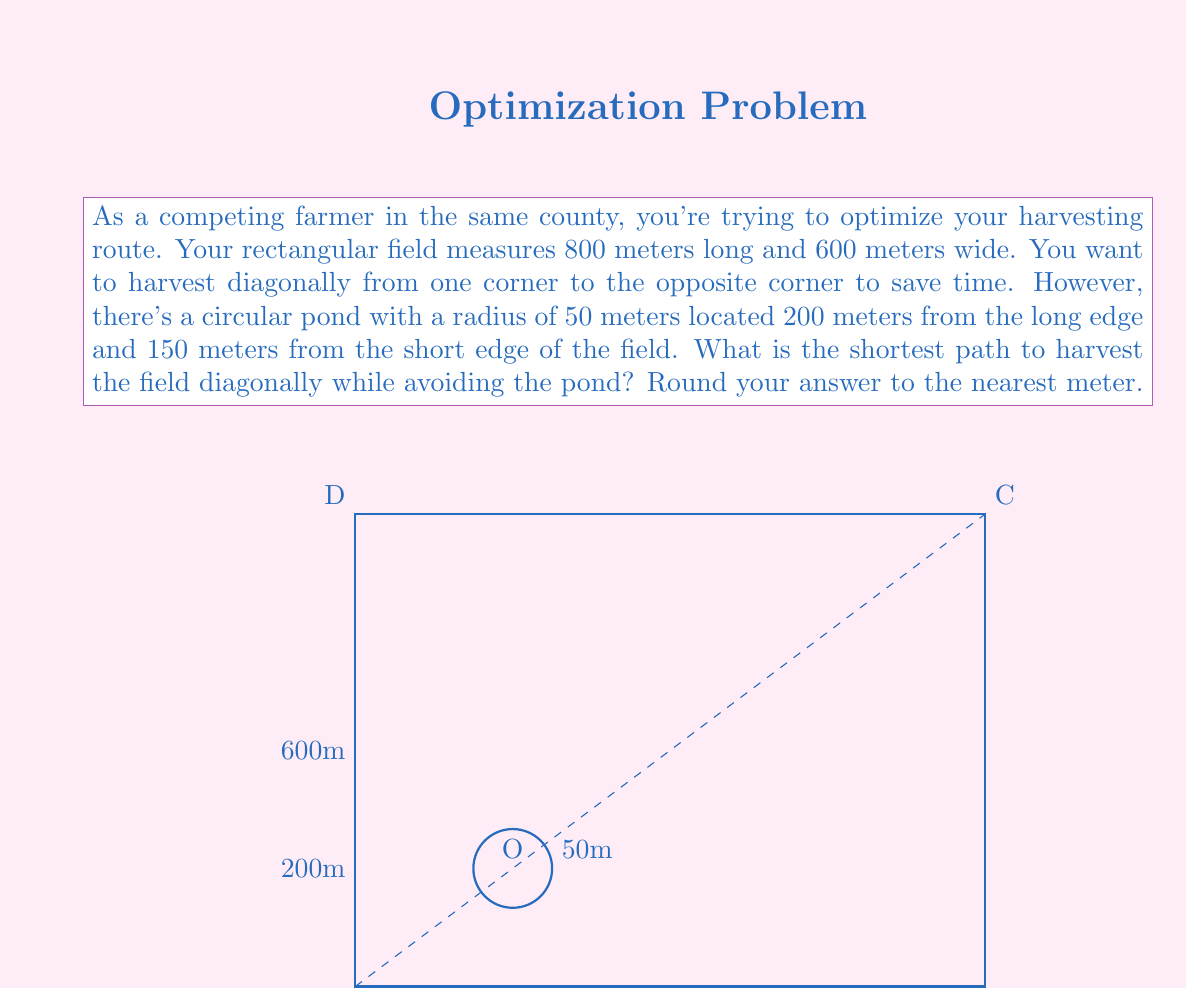What is the answer to this math problem? To solve this problem, we'll use trigonometry and path optimization techniques. Let's break it down step by step:

1) First, calculate the direct diagonal distance:
   $$d = \sqrt{800^2 + 600^2} = \sqrt{1,000,000} = 1000 \text{ meters}$$

2) Now, we need to check if this direct path intersects with the pond. The equation of the line AC is:
   $$y = \frac{3}{4}x$$

3) The distance from the center of the pond (200, 150) to this line is:
   $$\frac{|150 - \frac{3}{4}(200)|}{\sqrt{1 + (\frac{3}{4})^2}} \approx 55.9 \text{ meters}$$

4) Since this is greater than the pond's radius (50m), the direct path doesn't intersect the pond. Therefore, the shortest path is the direct diagonal.

5) However, for safety and practical reasons, we might want to keep a buffer distance from the pond. Let's say we want to stay 10 meters away from the edge of the pond.

6) Now we need to find tangent points on a circle with radius 60m (50m + 10m buffer). We can do this by solving the system of equations:

   Circle equation: $(x-200)^2 + (y-150)^2 = 60^2$
   Line equation: $y = \frac{3}{4}x$

7) Solving this system (which can be done using the quadratic formula) gives us two points of tangency. Let's call them P and Q.

8) The optimal path will now be A to P, then along the arc of the circle to Q, then Q to C.

9) Calculate distances AP, PQ (along the arc), and QC using trigonometry and the arc length formula.

10) Sum these distances for the total optimal path length.
Answer: The shortest path while maintaining a 10-meter buffer from the pond is approximately 1,006 meters. 